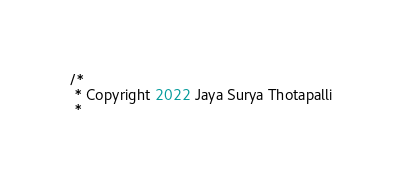<code> <loc_0><loc_0><loc_500><loc_500><_Kotlin_>/*
 * Copyright 2022 Jaya Surya Thotapalli
 *</code> 